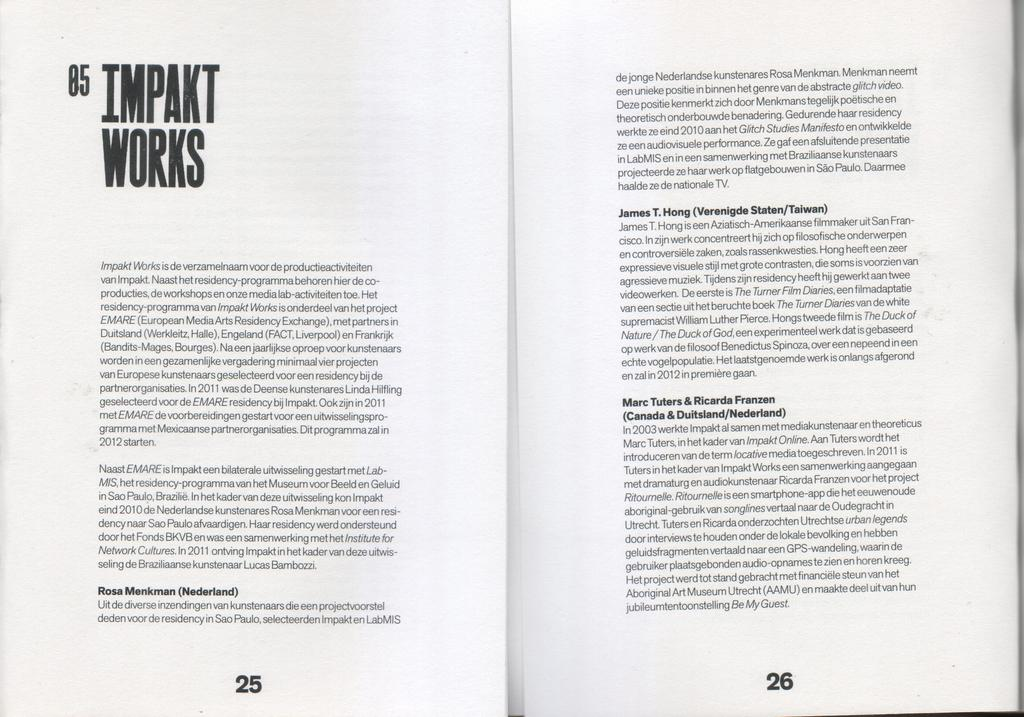<image>
Provide a brief description of the given image. A book is open to chapter 5 Impakt Works on page 25 